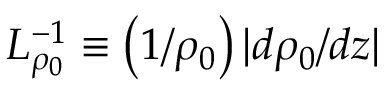<formula> <loc_0><loc_0><loc_500><loc_500>L _ { \rho _ { 0 } } ^ { - 1 } \equiv \left ( 1 / \rho _ { 0 } \right ) | d \rho _ { 0 } / d z |</formula> 